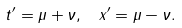Convert formula to latex. <formula><loc_0><loc_0><loc_500><loc_500>t ^ { \prime } = \mu + \nu , \, \ x ^ { \prime } = \mu - \nu .</formula> 